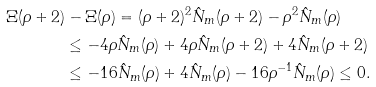<formula> <loc_0><loc_0><loc_500><loc_500>\Xi ( \rho + 2 ) & - \Xi ( \rho ) = ( \rho + 2 ) ^ { 2 } \hat { N } _ { m } ( \rho + 2 ) - \rho ^ { 2 } \hat { N } _ { m } ( \rho ) \\ & \leq - 4 \rho \hat { N } _ { m } ( \rho ) + 4 \rho \hat { N } _ { m } ( \rho + 2 ) + 4 \hat { N } _ { m } ( \rho + 2 ) \\ & \leq - 1 6 \hat { N } _ { m } ( \rho ) + 4 \hat { N } _ { m } ( \rho ) - 1 6 \rho ^ { - 1 } \hat { N } _ { m } ( \rho ) \leq 0 .</formula> 